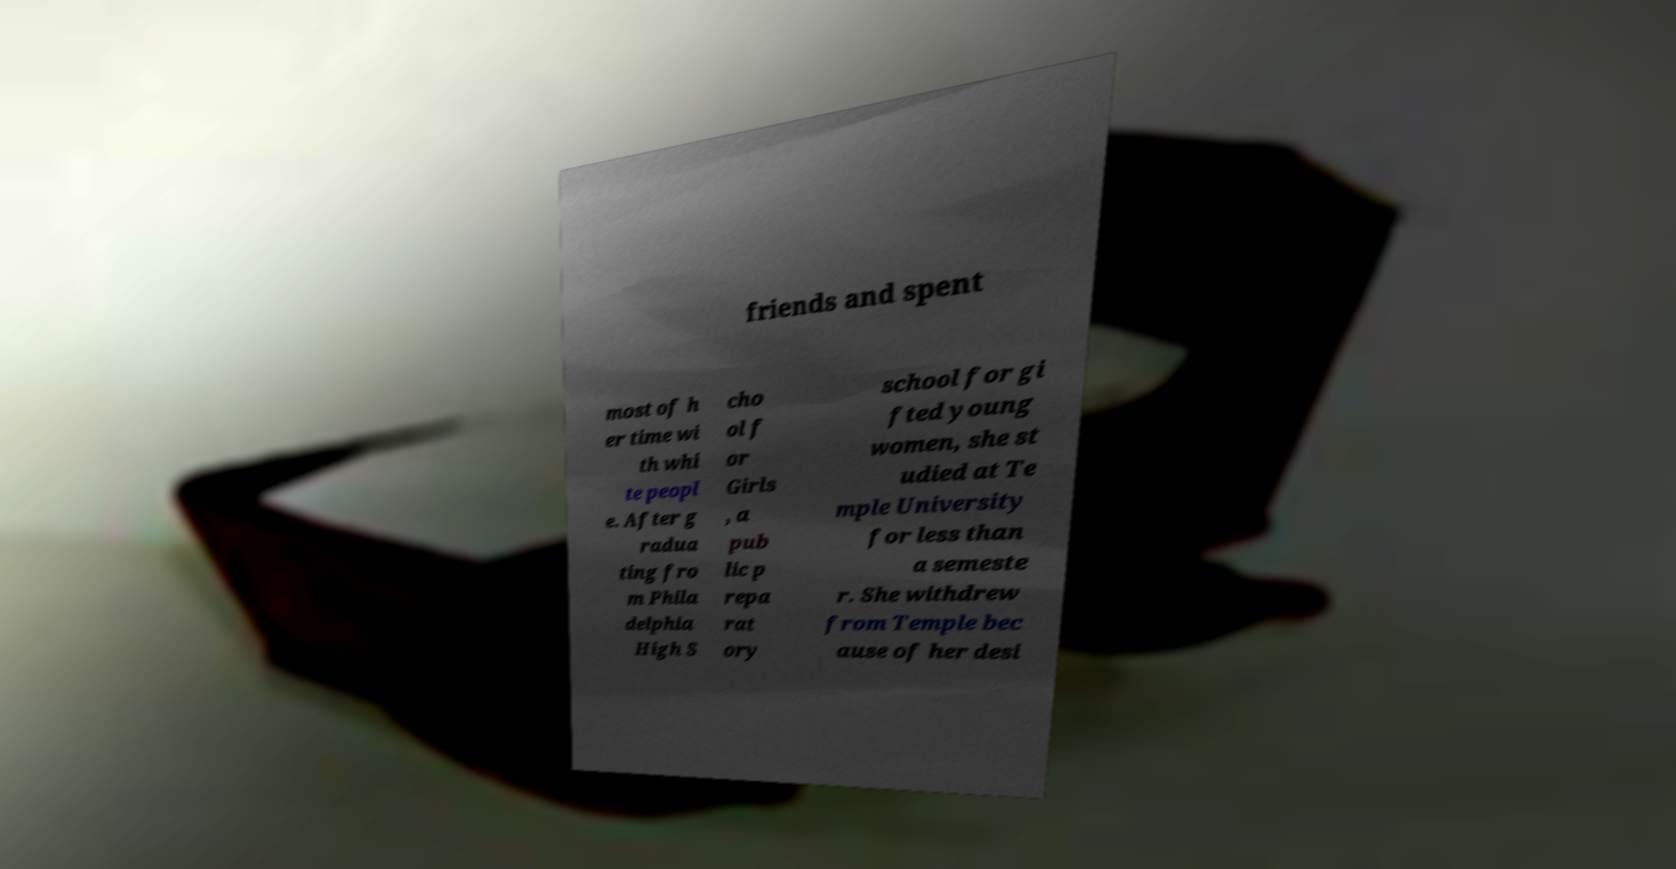What messages or text are displayed in this image? I need them in a readable, typed format. friends and spent most of h er time wi th whi te peopl e. After g radua ting fro m Phila delphia High S cho ol f or Girls , a pub lic p repa rat ory school for gi fted young women, she st udied at Te mple University for less than a semeste r. She withdrew from Temple bec ause of her desi 